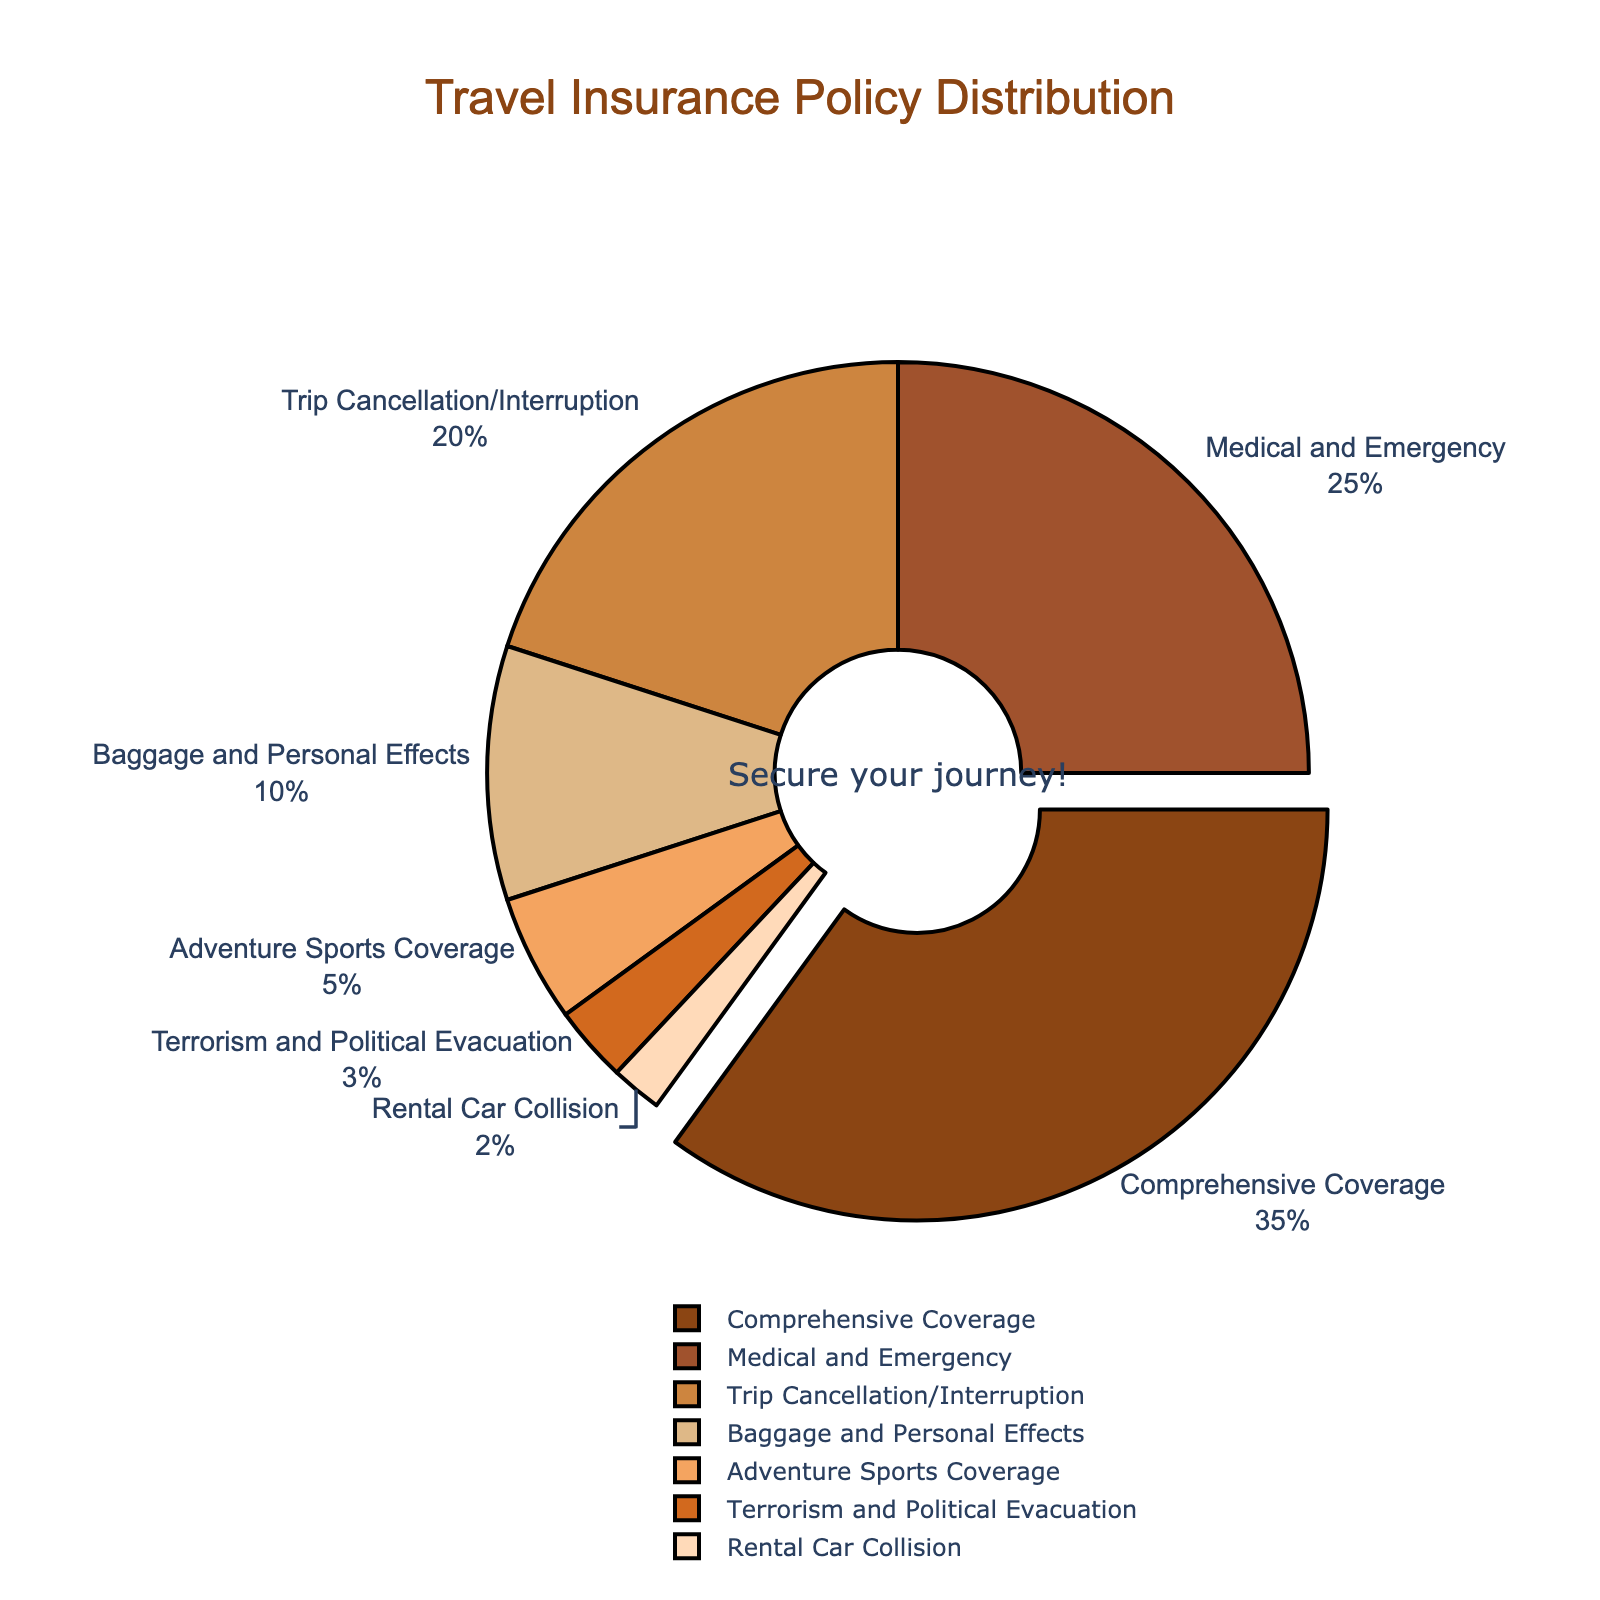What type of travel insurance is chosen most frequently? The figure shows that Comprehensive Coverage has the largest slice of the pie chart, representing 35% of all travel insurance policies chosen.
Answer: Comprehensive Coverage What is the total percentage of policies that cover Medical and Emergency, Trip Cancellation/Interruption, and Adventure Sports Coverage? Add the percentages for Medical and Emergency (25%), Trip Cancellation/Interruption (20%), and Adventure Sports Coverage (5%): 25 + 20 + 5 = 50.
Answer: 50% Which type of travel insurance has the smallest proportion? The smallest slice in the pie chart is for Rental Car Collision, which represents 2% of all travel insurance policies chosen.
Answer: Rental Car Collision How do the combined percentages of Baggage and Personal Effects, Adventure Sports Coverage, and Terrorism and Political Evacuation compare to Comprehensive Coverage? Sum the percentages for Baggage and Personal Effects (10%), Adventure Sports Coverage (5%), and Terrorism and Political Evacuation (3%): 10 + 5 + 3 = 18%. Comparing 18% to Comprehensive Coverage's 35%, 18% is less.
Answer: Less What visual clue is used to highlight the type of insurance chosen most frequently? The pie chart pulls out the slice for Comprehensive Coverage more than other slices, making it stand out visually.
Answer: Pull-out slice How does the proportion of Medical and Emergency insurance compare to Trip Cancellation/Interruption insurance? The pie chart shows that Medical and Emergency insurance has 25%, whereas Trip Cancellation/Interruption has 20%, so Medical and Emergency is chosen more frequently.
Answer: More frequently What is the percentage difference between Comprehensive Coverage and Adventure Sports Coverage? Subtract the percentage of Adventure Sports Coverage (5%) from Comprehensive Coverage (35%): 35 - 5 = 30%.
Answer: 30% What is the color of the segment for Baggage and Personal Effects insurance? The color of the Baggage and Personal Effects segment is identified as a lighter brown shade in the pie chart.
Answer: Lighter brown shade How many types of travel insurance policies have a percentage less than 10%? The pie chart shows that Adventure Sports Coverage (5%), Terrorism and Political Evacuation (3%), and Rental Car Collision (2%) each have less than 10%. So there are three types.
Answer: Three types Are there more types of insurance policies with percentages greater than or equal to 10% or less than 10%? There are four types with percentages greater than or equal to 10% (Comprehensive Coverage, Medical and Emergency, Trip Cancellation/Interruption, Baggage and Personal Effects) and three types with less than 10%.
Answer: Greater than or equal to 10% 